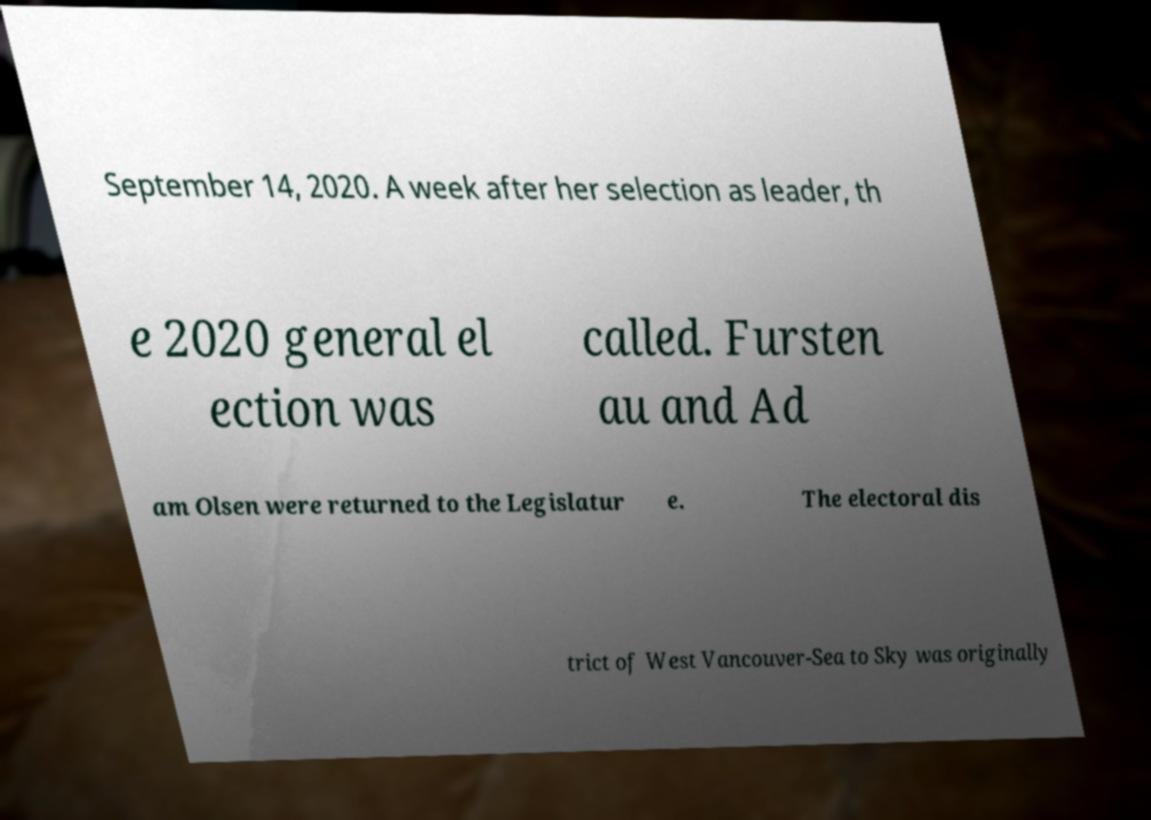I need the written content from this picture converted into text. Can you do that? September 14, 2020. A week after her selection as leader, th e 2020 general el ection was called. Fursten au and Ad am Olsen were returned to the Legislatur e. The electoral dis trict of West Vancouver-Sea to Sky was originally 